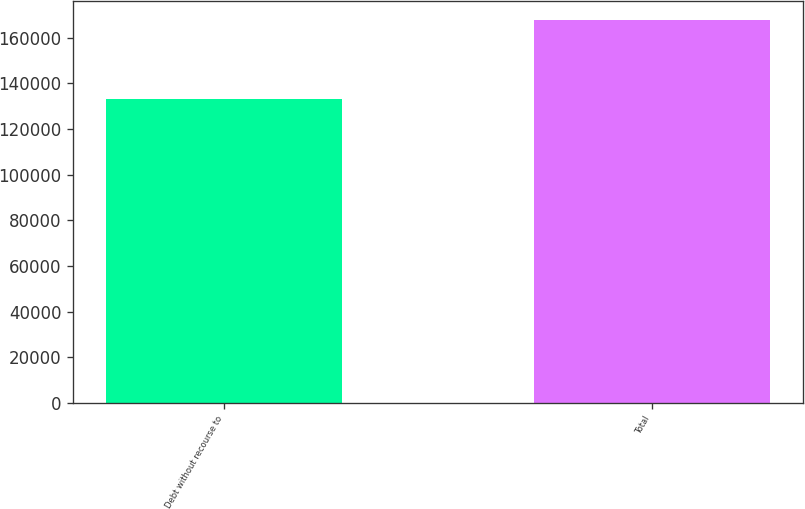<chart> <loc_0><loc_0><loc_500><loc_500><bar_chart><fcel>Debt without recourse to<fcel>Total<nl><fcel>133388<fcel>167592<nl></chart> 